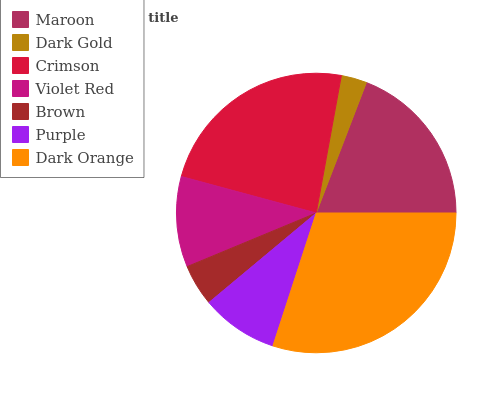Is Dark Gold the minimum?
Answer yes or no. Yes. Is Dark Orange the maximum?
Answer yes or no. Yes. Is Crimson the minimum?
Answer yes or no. No. Is Crimson the maximum?
Answer yes or no. No. Is Crimson greater than Dark Gold?
Answer yes or no. Yes. Is Dark Gold less than Crimson?
Answer yes or no. Yes. Is Dark Gold greater than Crimson?
Answer yes or no. No. Is Crimson less than Dark Gold?
Answer yes or no. No. Is Violet Red the high median?
Answer yes or no. Yes. Is Violet Red the low median?
Answer yes or no. Yes. Is Dark Gold the high median?
Answer yes or no. No. Is Crimson the low median?
Answer yes or no. No. 